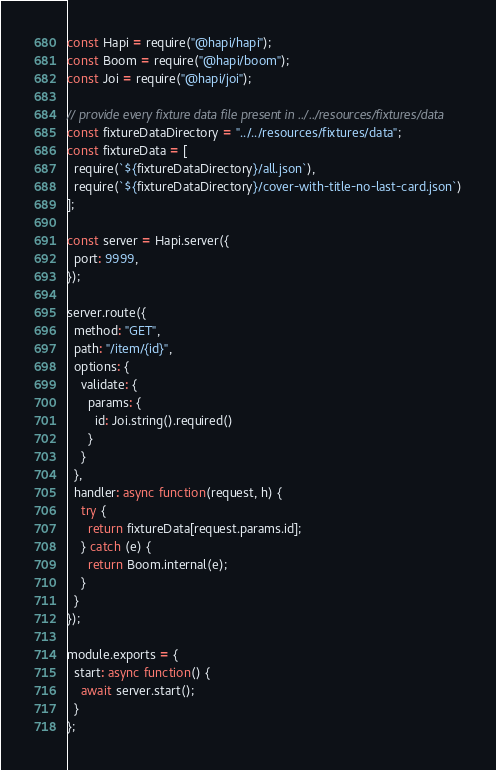<code> <loc_0><loc_0><loc_500><loc_500><_JavaScript_>const Hapi = require("@hapi/hapi");
const Boom = require("@hapi/boom");
const Joi = require("@hapi/joi");

// provide every fixture data file present in ../../resources/fixtures/data
const fixtureDataDirectory = "../../resources/fixtures/data";
const fixtureData = [
  require(`${fixtureDataDirectory}/all.json`),
  require(`${fixtureDataDirectory}/cover-with-title-no-last-card.json`)
];

const server = Hapi.server({
  port: 9999,
});

server.route({
  method: "GET",
  path: "/item/{id}",
  options: {
    validate: {
      params: {
        id: Joi.string().required()
      }
    }
  },
  handler: async function(request, h) {
    try {
      return fixtureData[request.params.id];
    } catch (e) {
      return Boom.internal(e);
    }
  }
});

module.exports = {
  start: async function() {
    await server.start();
  }
};
</code> 